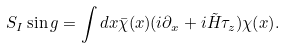<formula> <loc_0><loc_0><loc_500><loc_500>S _ { I } \sin g = \int d x \bar { \chi } ( x ) ( i \partial _ { x } + i \tilde { H } \tau _ { z } ) \chi ( x ) .</formula> 